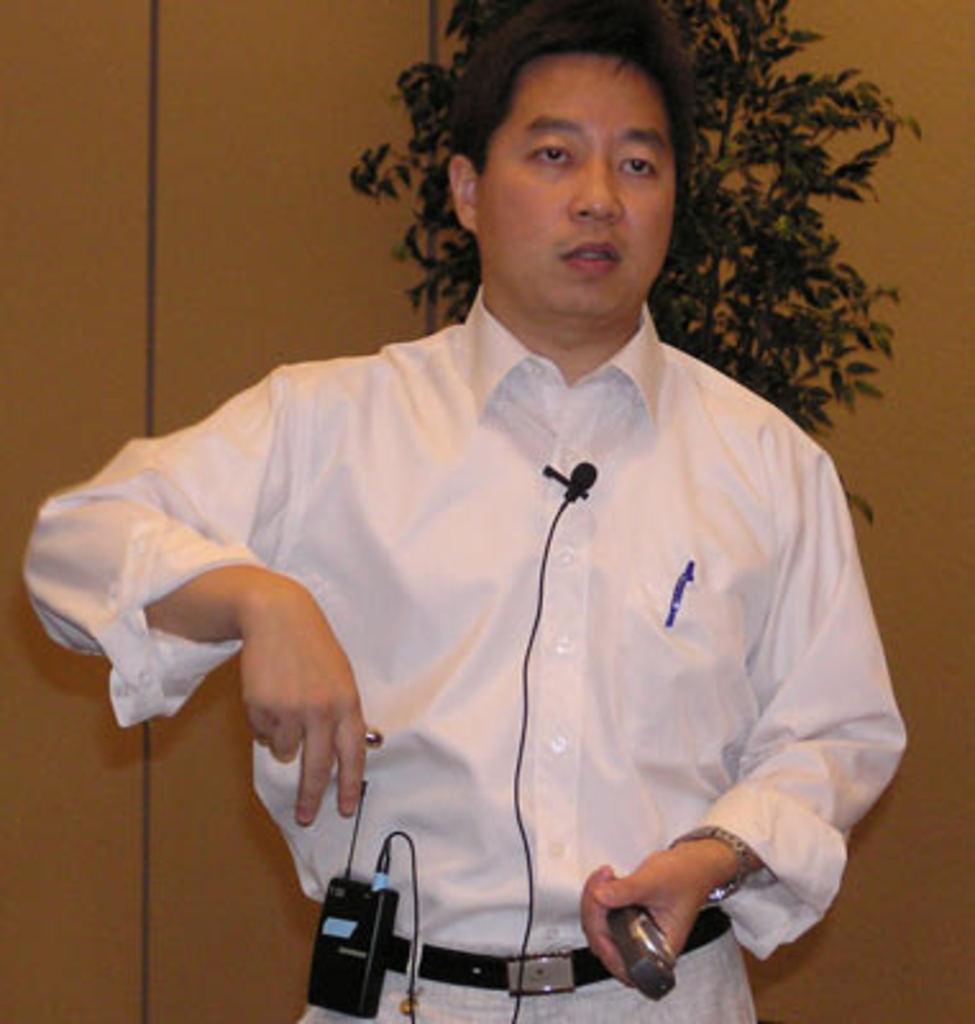Describe this image in one or two sentences. In this image we can see a man wearing the shirt and holding an object and also standing. In the background we can see the wall and also a plant. 